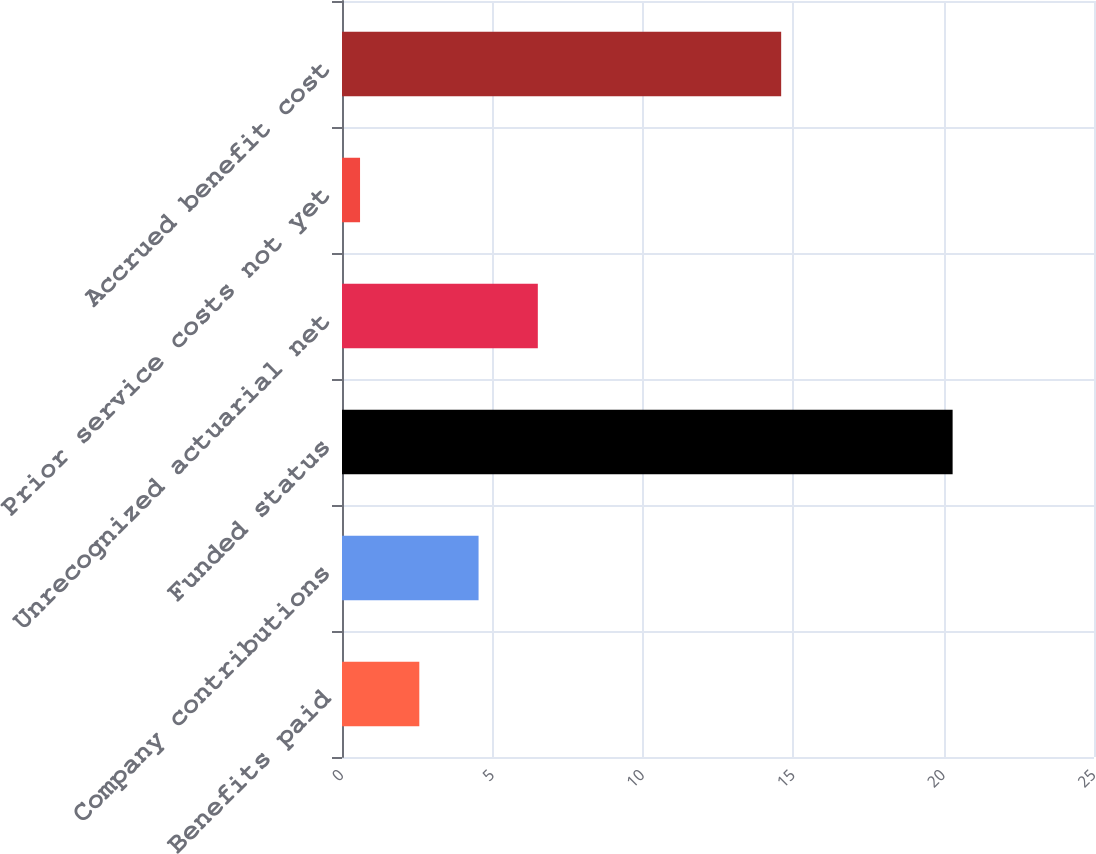Convert chart to OTSL. <chart><loc_0><loc_0><loc_500><loc_500><bar_chart><fcel>Benefits paid<fcel>Company contributions<fcel>Funded status<fcel>Unrecognized actuarial net<fcel>Prior service costs not yet<fcel>Accrued benefit cost<nl><fcel>2.57<fcel>4.54<fcel>20.3<fcel>6.51<fcel>0.6<fcel>14.6<nl></chart> 